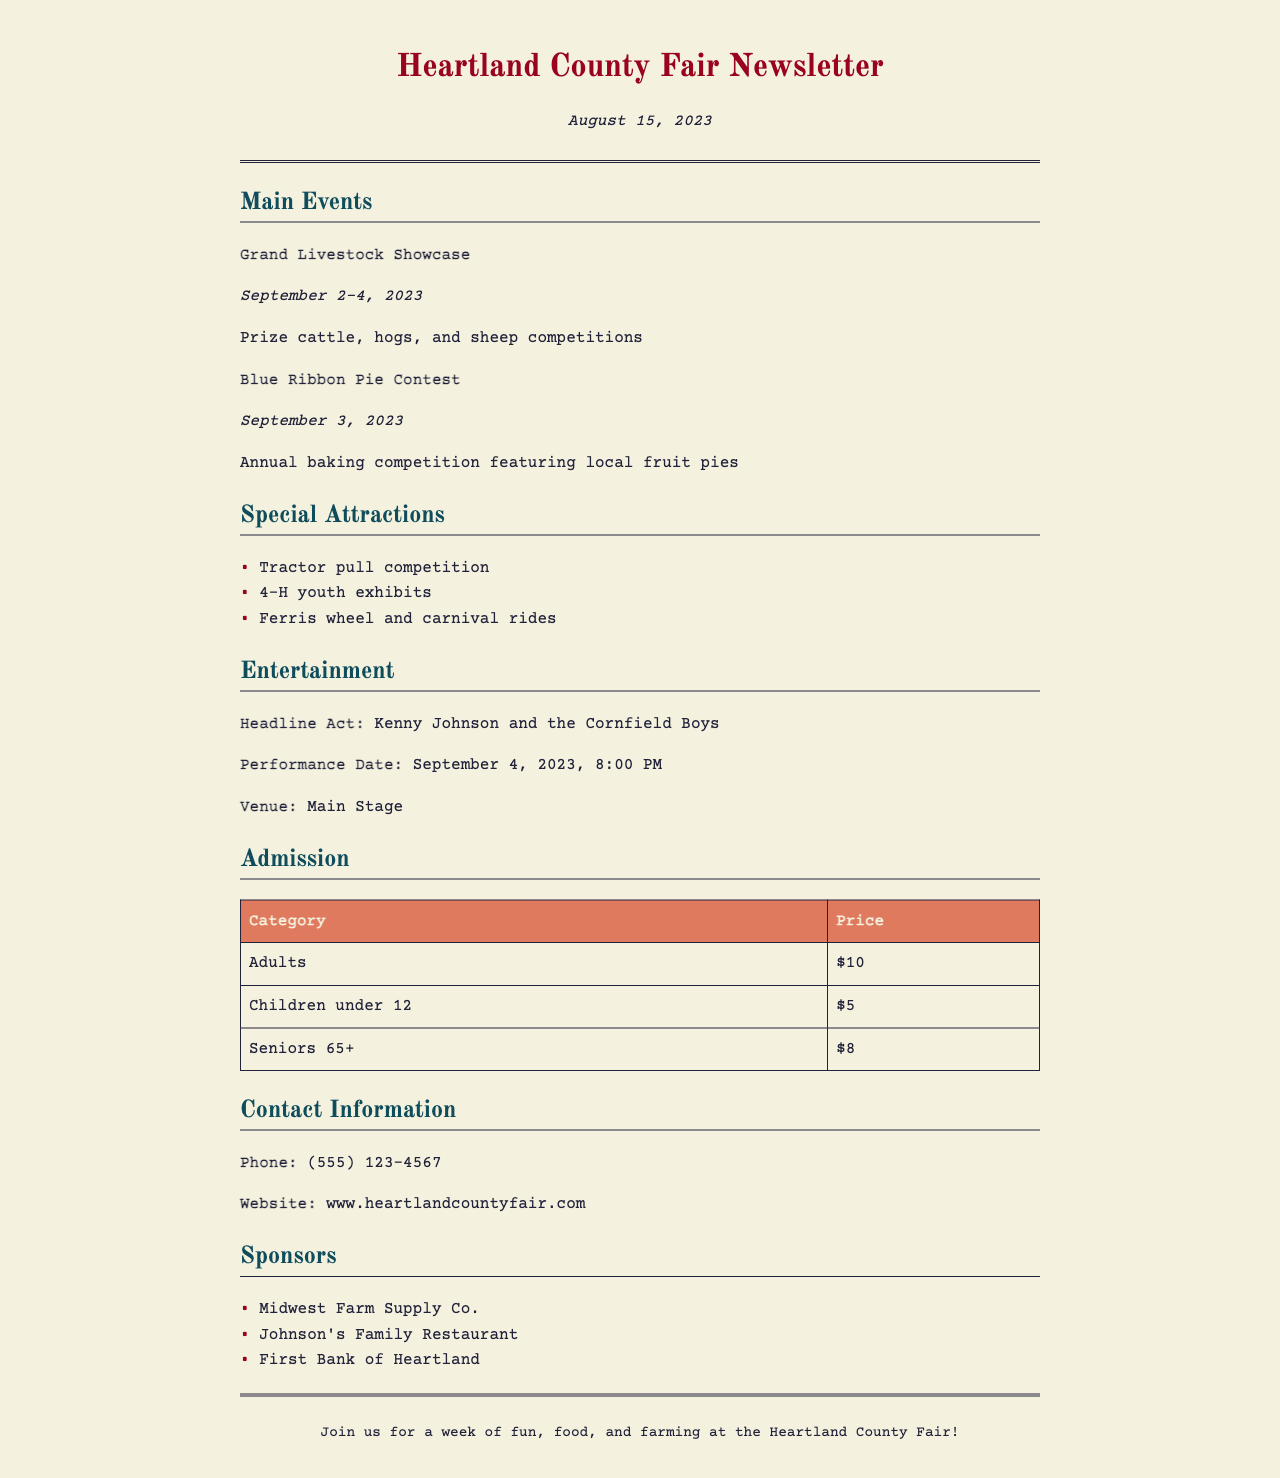What are the dates of the Grand Livestock Showcase? The Grand Livestock Showcase takes place from September 2 to September 4, 2023.
Answer: September 2-4, 2023 What is the prize for the Blue Ribbon Pie Contest? The winners of the Blue Ribbon Pie Contest are recognized in an annual competition featuring local fruit pies.
Answer: Annual baking competition Who is the headline act for the fair? The headline act, Kenny Johnson and the Cornfield Boys, is scheduled to perform on September 4.
Answer: Kenny Johnson and the Cornfield Boys How much does admission cost for children under 12? The admission price for children under 12 is $5.
Answer: $5 What special attraction features youth exhibits? The fair includes 4-H youth exhibits as a special attraction.
Answer: 4-H youth exhibits What is the performance date for the headline act? The performance of the headline act is scheduled for September 4, 2023, at 8:00 PM.
Answer: September 4, 2023, 8:00 PM How many main events are listed in the newsletter? There are two main events listed in the newsletter: the Grand Livestock Showcase and the Blue Ribbon Pie Contest.
Answer: Two What company is a sponsor of the Heartland County Fair? Sponsors include Midwest Farm Supply Co., among others.
Answer: Midwest Farm Supply Co What is the venue for the entertainment act? The venue for the entertainment act is the Main Stage.
Answer: Main Stage 